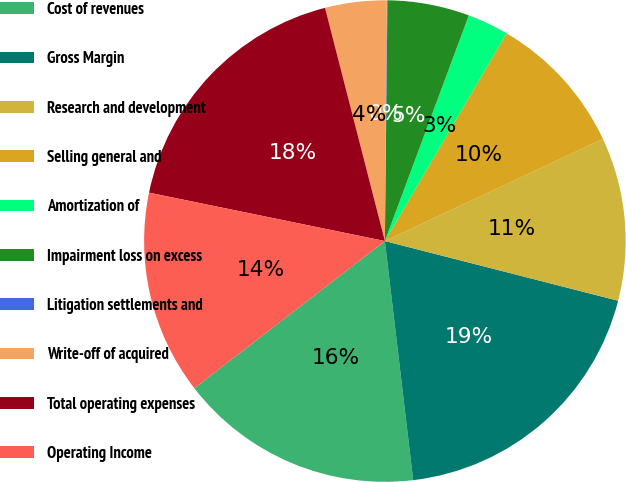<chart> <loc_0><loc_0><loc_500><loc_500><pie_chart><fcel>Cost of revenues<fcel>Gross Margin<fcel>Research and development<fcel>Selling general and<fcel>Amortization of<fcel>Impairment loss on excess<fcel>Litigation settlements and<fcel>Write-off of acquired<fcel>Total operating expenses<fcel>Operating Income<nl><fcel>16.41%<fcel>19.14%<fcel>10.96%<fcel>9.59%<fcel>2.77%<fcel>5.5%<fcel>0.04%<fcel>4.13%<fcel>17.78%<fcel>13.69%<nl></chart> 